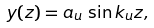Convert formula to latex. <formula><loc_0><loc_0><loc_500><loc_500>y ( z ) = a _ { u } \, \sin k _ { u } z ,</formula> 